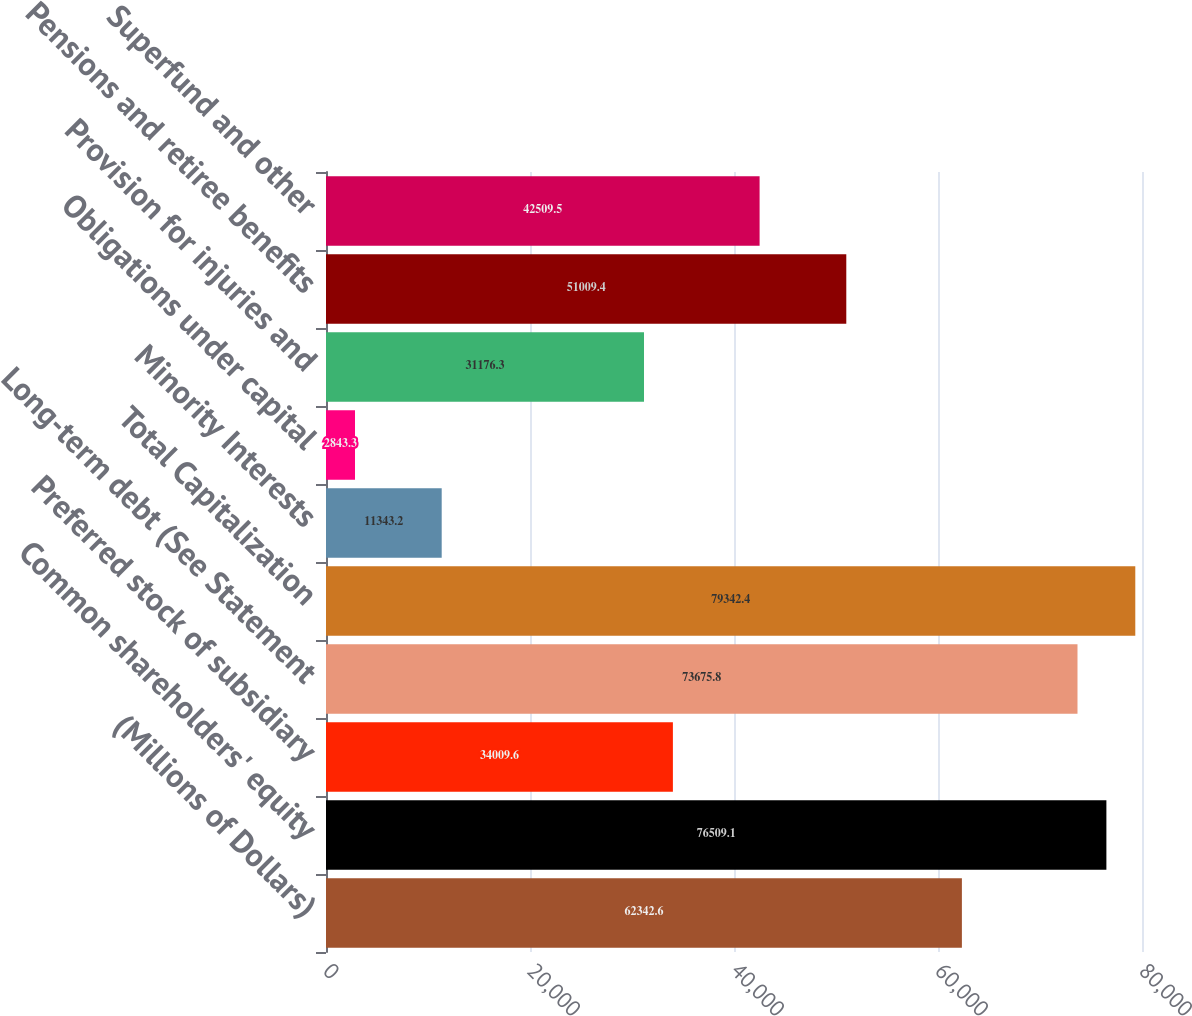Convert chart to OTSL. <chart><loc_0><loc_0><loc_500><loc_500><bar_chart><fcel>(Millions of Dollars)<fcel>Common shareholders' equity<fcel>Preferred stock of subsidiary<fcel>Long-term debt (See Statement<fcel>Total Capitalization<fcel>Minority Interests<fcel>Obligations under capital<fcel>Provision for injuries and<fcel>Pensions and retiree benefits<fcel>Superfund and other<nl><fcel>62342.6<fcel>76509.1<fcel>34009.6<fcel>73675.8<fcel>79342.4<fcel>11343.2<fcel>2843.3<fcel>31176.3<fcel>51009.4<fcel>42509.5<nl></chart> 